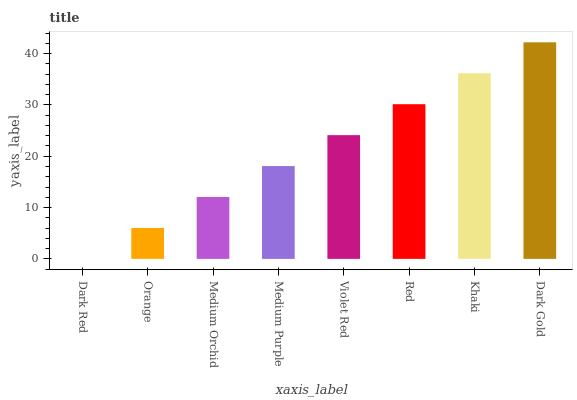Is Orange the minimum?
Answer yes or no. No. Is Orange the maximum?
Answer yes or no. No. Is Orange greater than Dark Red?
Answer yes or no. Yes. Is Dark Red less than Orange?
Answer yes or no. Yes. Is Dark Red greater than Orange?
Answer yes or no. No. Is Orange less than Dark Red?
Answer yes or no. No. Is Violet Red the high median?
Answer yes or no. Yes. Is Medium Purple the low median?
Answer yes or no. Yes. Is Medium Purple the high median?
Answer yes or no. No. Is Violet Red the low median?
Answer yes or no. No. 